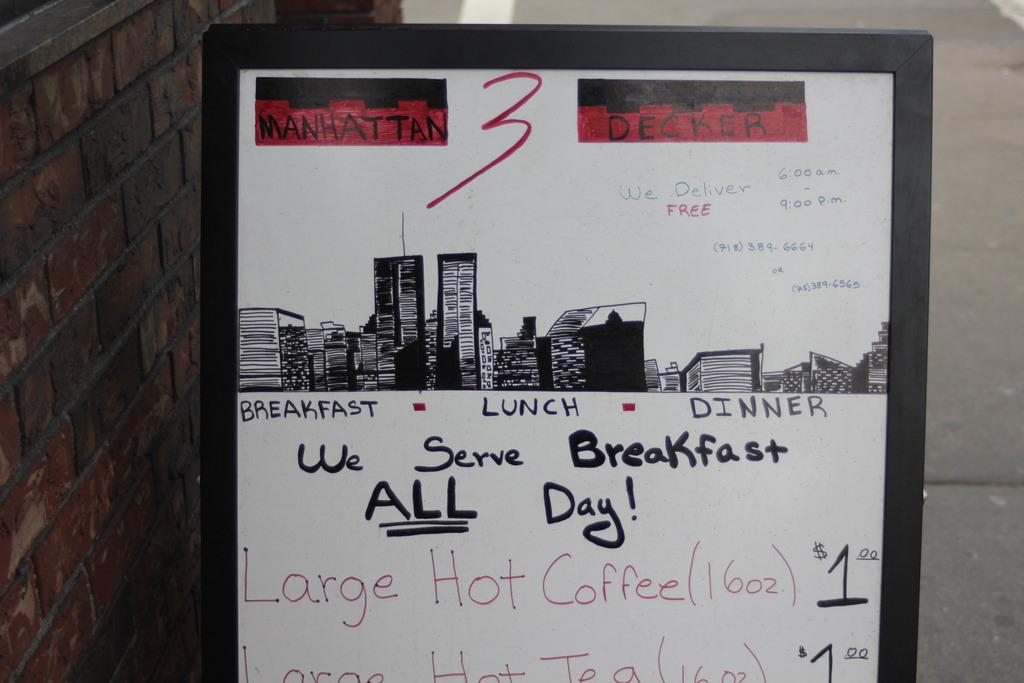<image>
Give a short and clear explanation of the subsequent image. A menu board for a restaurant that serves breakfast all day. 